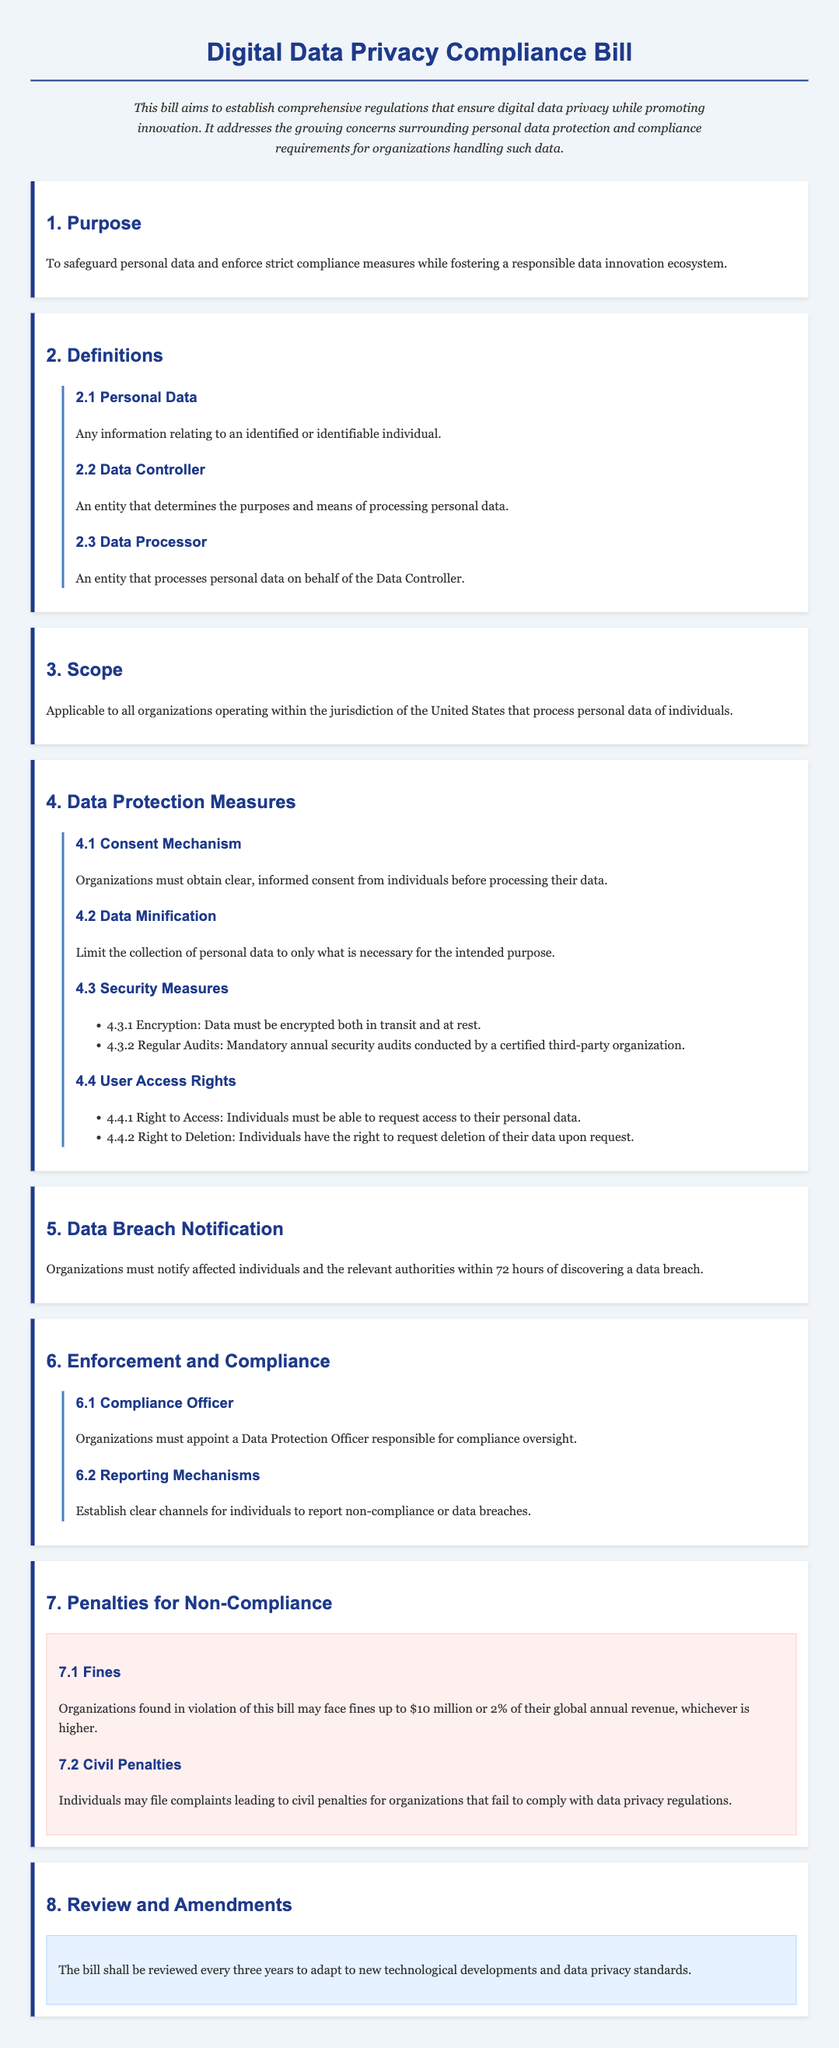What is the maximum fine for non-compliance? The document states that organizations may face fines up to $10 million or 2% of their global annual revenue, whichever is higher.
Answer: $10 million or 2% of global annual revenue What is required before processing personal data according to the bill? The bill specifies that organizations must obtain clear, informed consent from individuals before processing their data.
Answer: Clear, informed consent What should organizations do within 72 hours of a data breach? According to the bill, organizations must notify affected individuals and the relevant authorities about the data breach within 72 hours.
Answer: Notify affected individuals and authorities How often will the bill be reviewed? The document states that the bill shall be reviewed every three years to adapt to new standards.
Answer: Every three years Who must organizations appoint for compliance oversight? The bill mandates organizations to appoint a Data Protection Officer responsible for compliance oversight.
Answer: Data Protection Officer What is data minification? The document defines data minification as limiting the collection of personal data to only what is necessary for the intended purpose.
Answer: Limiting data collection to necessity What rights do individuals have regarding their personal data? The bill grants individuals the right to request access to their personal data and the deletion of their data upon request.
Answer: Right to access and deletion What mechanism is established for reporting non-compliance? The document specifies that organizations should establish clear channels for individuals to report non-compliance or data breaches.
Answer: Clear reporting channels 